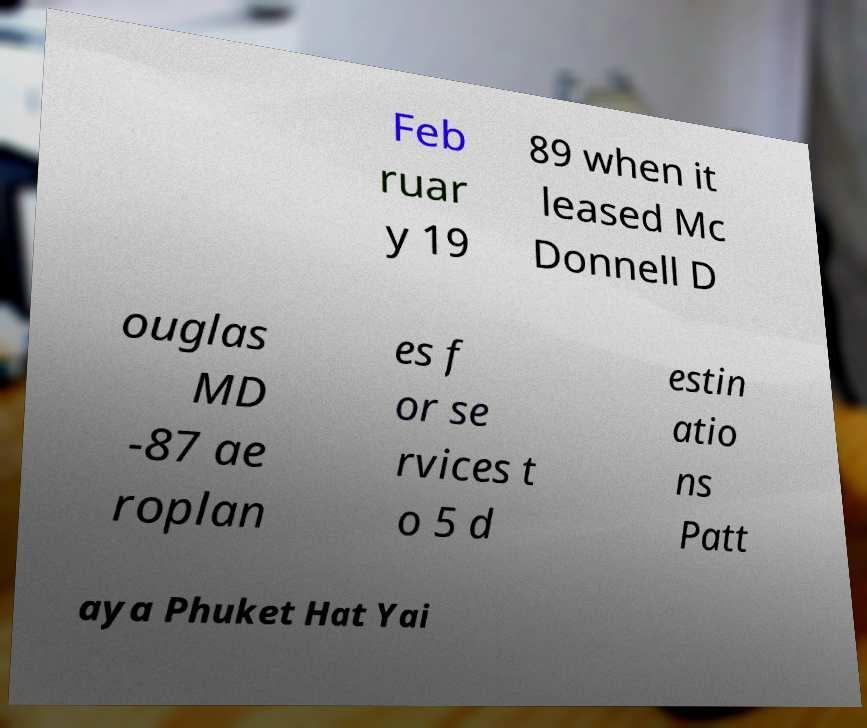Can you read and provide the text displayed in the image?This photo seems to have some interesting text. Can you extract and type it out for me? Feb ruar y 19 89 when it leased Mc Donnell D ouglas MD -87 ae roplan es f or se rvices t o 5 d estin atio ns Patt aya Phuket Hat Yai 